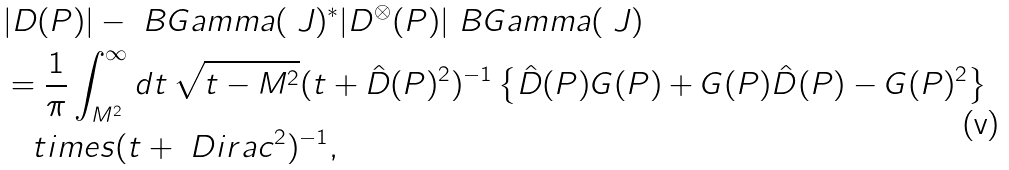Convert formula to latex. <formula><loc_0><loc_0><loc_500><loc_500>& | D ( P ) | - \ B G a m m a ( \ J ) ^ { * } | D ^ { \otimes } ( P ) | \ B G a m m a ( \ J ) \\ & = \frac { 1 } { \pi } \int _ { M ^ { 2 } } ^ { \infty } d t \, \sqrt { t - M ^ { 2 } } ( t + \hat { D } ( P ) ^ { 2 } ) ^ { - 1 } \left \{ \hat { D } ( P ) G ( P ) + G ( P ) \hat { D } ( P ) - G ( P ) ^ { 2 } \right \} \\ & \quad t i m e s ( t + \ D i r a c ^ { 2 } ) ^ { - 1 } ,</formula> 